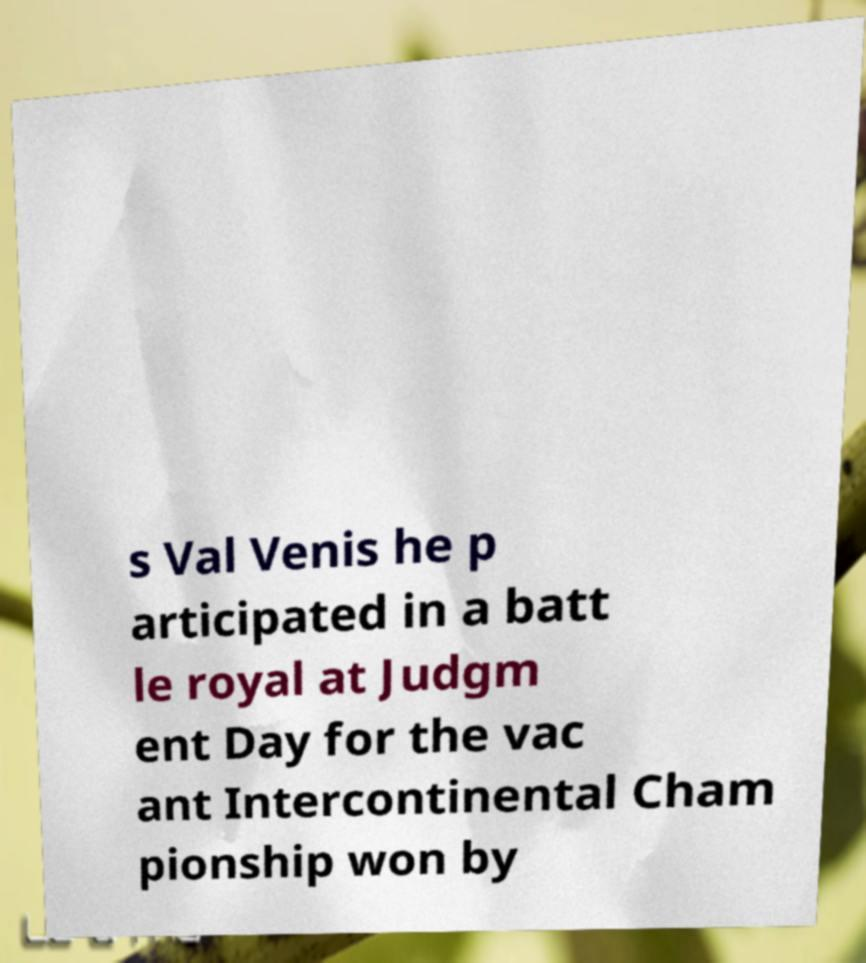I need the written content from this picture converted into text. Can you do that? s Val Venis he p articipated in a batt le royal at Judgm ent Day for the vac ant Intercontinental Cham pionship won by 